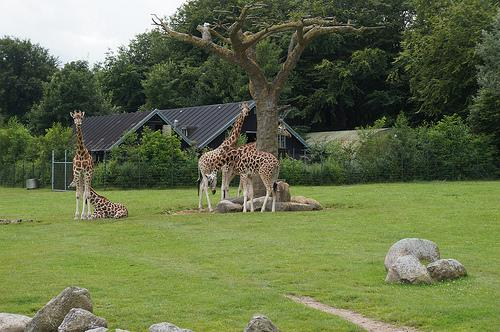Question: what color is the roof of the building?
Choices:
A. Black.
B. Red.
C. Gray.
D. Brown.
Answer with the letter. Answer: A Question: how many giraffes are there?
Choices:
A. 9.
B. 5.
C. 10.
D. 7.
Answer with the letter. Answer: B Question: what are three giraffes standing by?
Choices:
A. A lake.
B. A zebra.
C. A tree.
D. An explorer.
Answer with the letter. Answer: C Question: what is the weather like?
Choices:
A. Rainy.
B. Cloudy.
C. Snowing.
D. Sunny.
Answer with the letter. Answer: B Question: where is this photo taken?
Choices:
A. In a driveway.
B. In a basement.
C. At a zoo.
D. At a stadium.
Answer with the letter. Answer: C Question: how many giraffes are lying on the ground?
Choices:
A. One.
B. Two.
C. Three.
D. Four.
Answer with the letter. Answer: A 